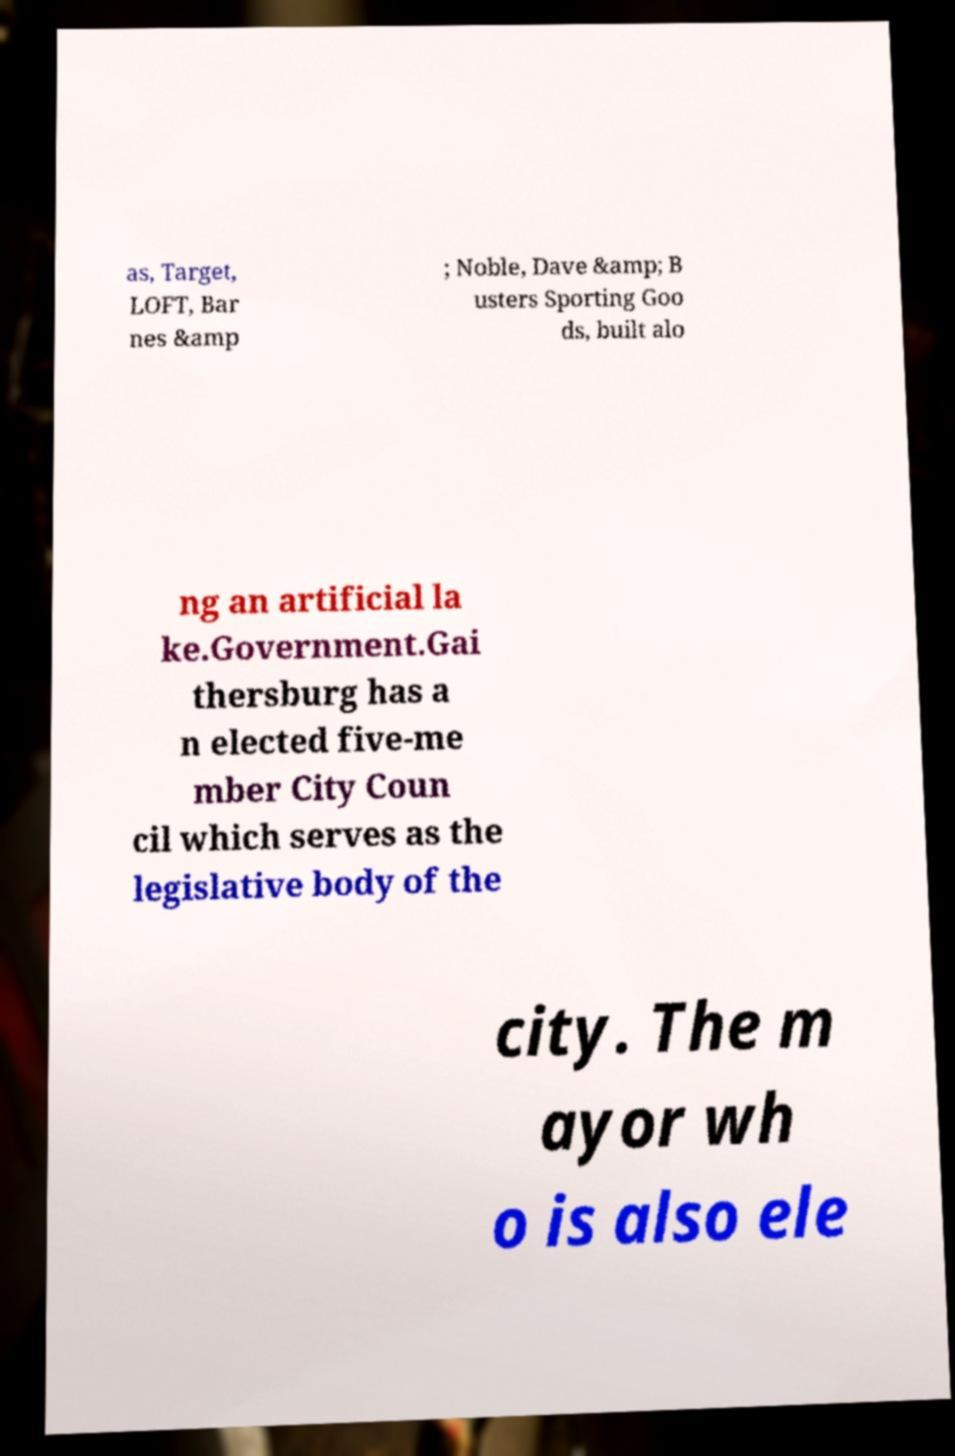I need the written content from this picture converted into text. Can you do that? as, Target, LOFT, Bar nes &amp ; Noble, Dave &amp; B usters Sporting Goo ds, built alo ng an artificial la ke.Government.Gai thersburg has a n elected five-me mber City Coun cil which serves as the legislative body of the city. The m ayor wh o is also ele 